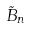<formula> <loc_0><loc_0><loc_500><loc_500>\tilde { B } _ { n }</formula> 